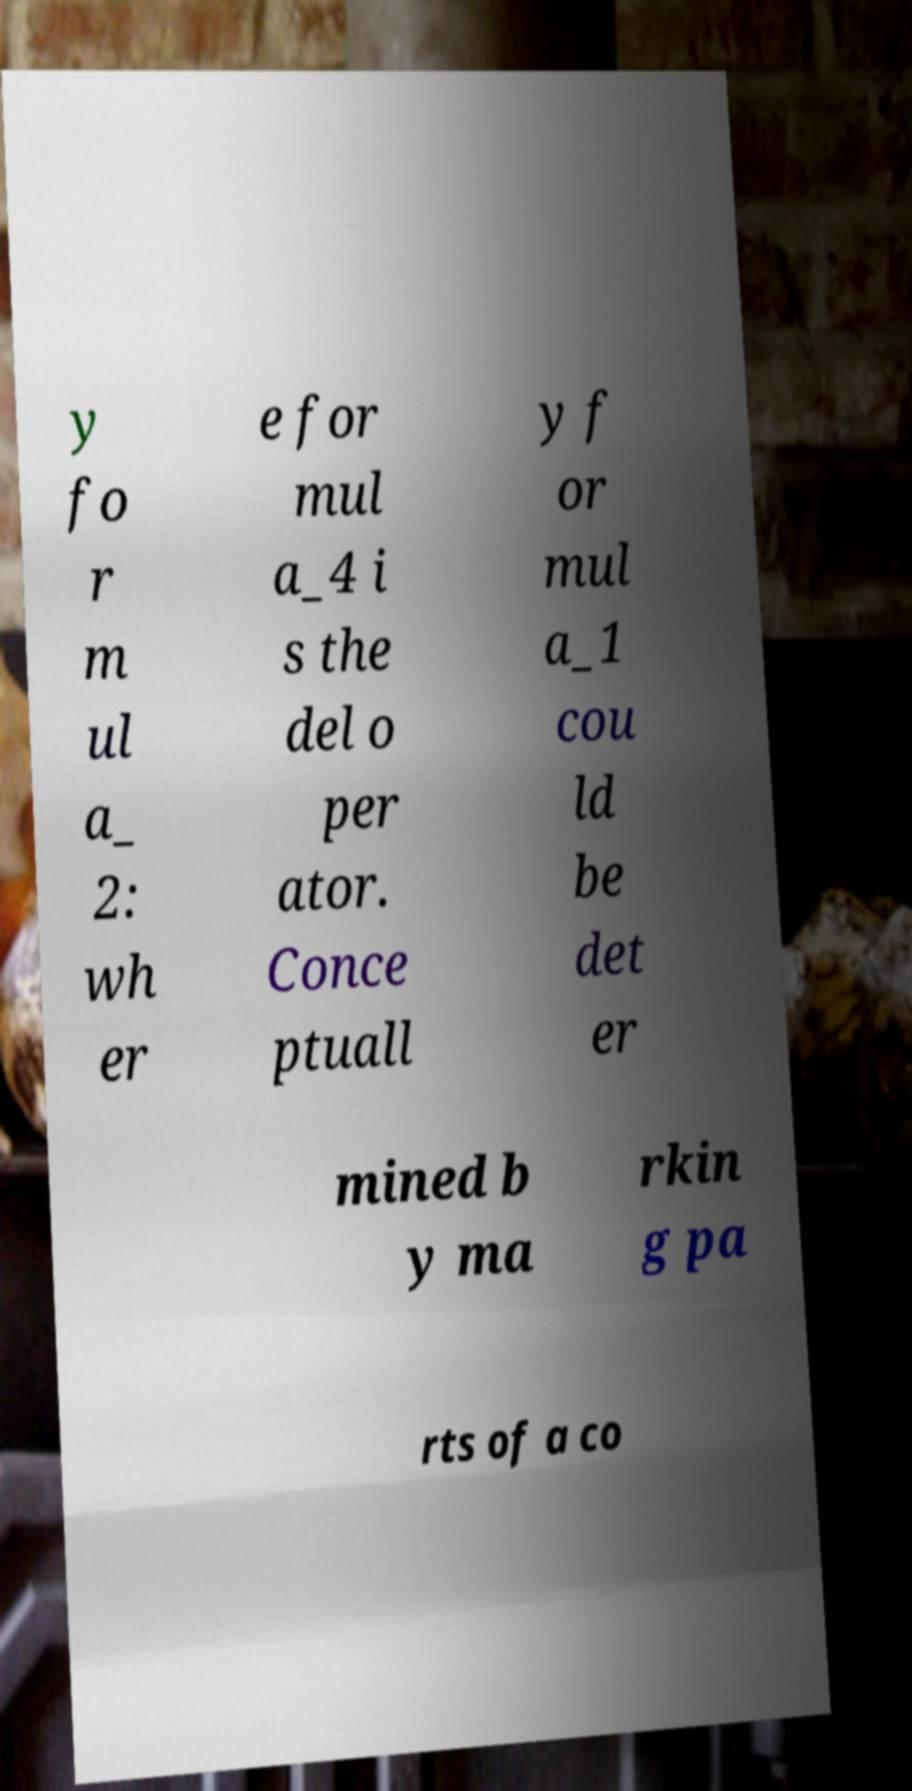Please identify and transcribe the text found in this image. y fo r m ul a_ 2: wh er e for mul a_4 i s the del o per ator. Conce ptuall y f or mul a_1 cou ld be det er mined b y ma rkin g pa rts of a co 